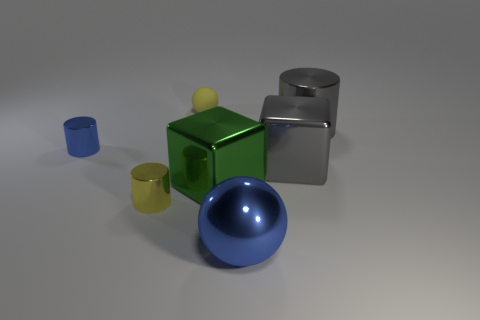Add 3 large red cylinders. How many objects exist? 10 Subtract all tiny cylinders. How many cylinders are left? 1 Subtract all brown balls. How many blue cylinders are left? 1 Add 3 cylinders. How many cylinders are left? 6 Add 7 big yellow metallic cylinders. How many big yellow metallic cylinders exist? 7 Subtract all green cubes. How many cubes are left? 1 Subtract 1 gray cylinders. How many objects are left? 6 Subtract all balls. How many objects are left? 5 Subtract all yellow cylinders. Subtract all gray blocks. How many cylinders are left? 2 Subtract all tiny yellow cubes. Subtract all big blue metallic balls. How many objects are left? 6 